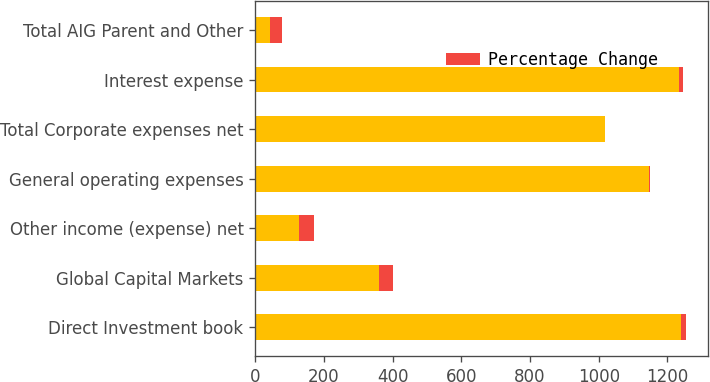Convert chart to OTSL. <chart><loc_0><loc_0><loc_500><loc_500><stacked_bar_chart><ecel><fcel>Direct Investment book<fcel>Global Capital Markets<fcel>Other income (expense) net<fcel>General operating expenses<fcel>Total Corporate expenses net<fcel>Interest expense<fcel>Total AIG Parent and Other<nl><fcel>nan<fcel>1241<fcel>359<fcel>128<fcel>1146<fcel>1018<fcel>1233<fcel>43<nl><fcel>Percentage Change<fcel>14<fcel>43<fcel>42<fcel>3<fcel>1<fcel>13<fcel>34<nl></chart> 